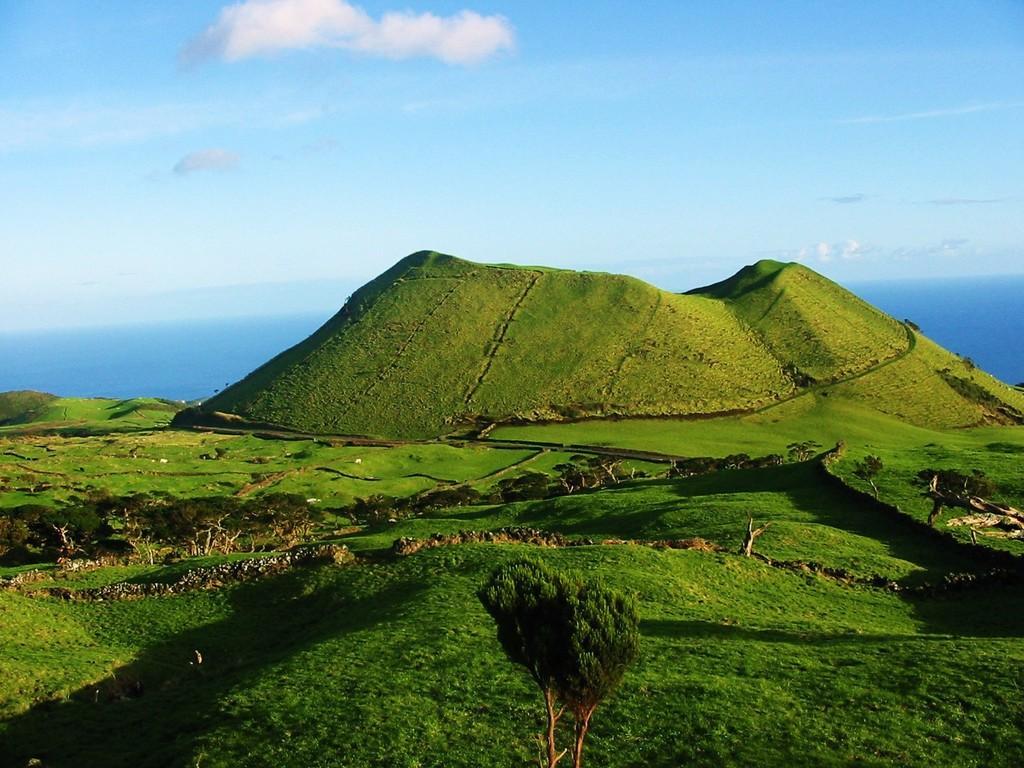Describe this image in one or two sentences. In this image I can see trees, the grass and other objects on the ground. In the background I can see the sky and the water. 